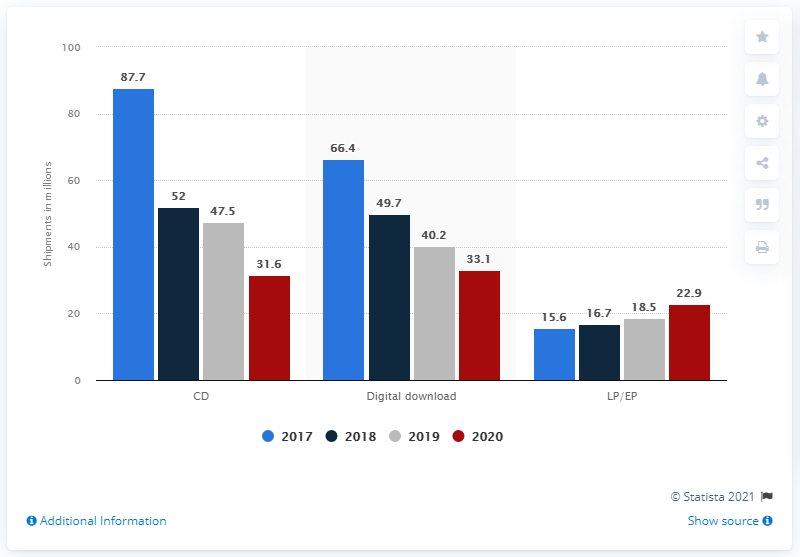Indicate a few pertinent items in this graphic. In 2020, a total of 31.6 million CD albums were shipped in the United States. In 2020, the shipments of LPs and EPs were 22.9 million units. In 2020, a total of 33.1 albums were downloaded. 